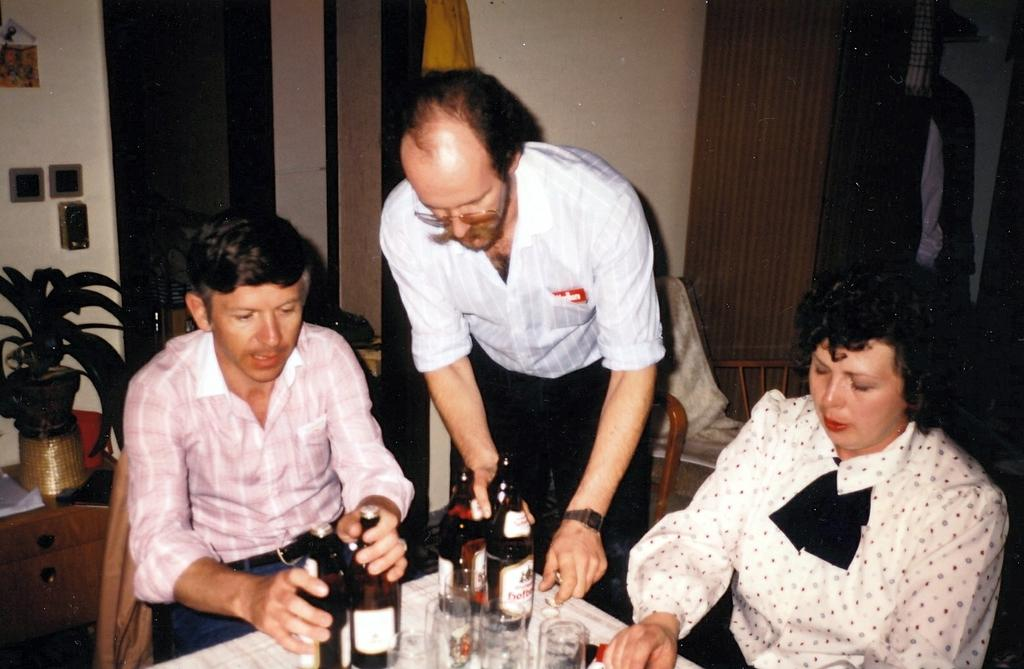How many people are in the image? There are three persons in the image. What are the persons doing in the image? The persons are having their drinks. What type of milk is being served in the image? There is no mention of milk or any specific drink being served in the image. 